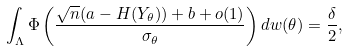Convert formula to latex. <formula><loc_0><loc_0><loc_500><loc_500>\int _ { \Lambda } \Phi \left ( \frac { \sqrt { n } ( a - H ( Y _ { \theta } ) ) + b + o ( 1 ) } { \sigma _ { \theta } } \right ) d w ( \theta ) = \frac { \delta } { 2 } ,</formula> 